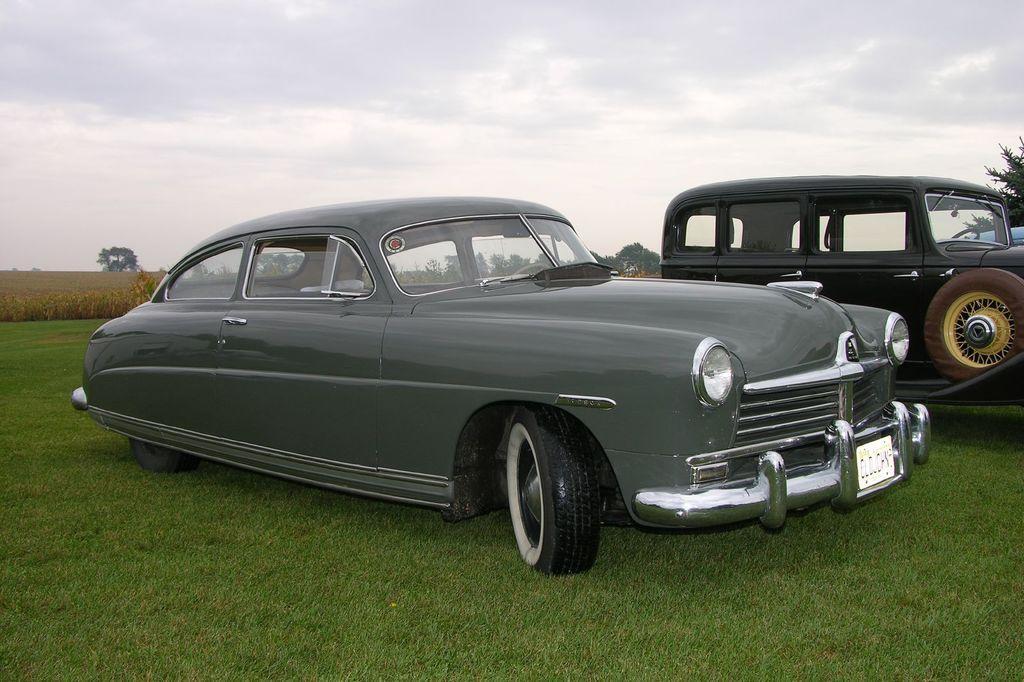Describe this image in one or two sentences. This image is taken outdoors. At the top of the image there is the sky with clouds. At the bottom of the image there is a ground with grass on it. In the background there are a few trees and plants on the ground. On the right side of the image three cars are parked on the ground. 